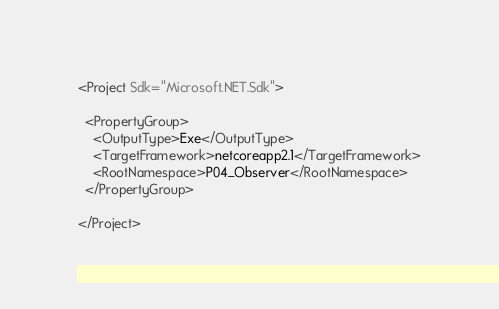<code> <loc_0><loc_0><loc_500><loc_500><_XML_><Project Sdk="Microsoft.NET.Sdk">

  <PropertyGroup>
    <OutputType>Exe</OutputType>
    <TargetFramework>netcoreapp2.1</TargetFramework>
    <RootNamespace>P04_Observer</RootNamespace>
  </PropertyGroup>

</Project>
</code> 